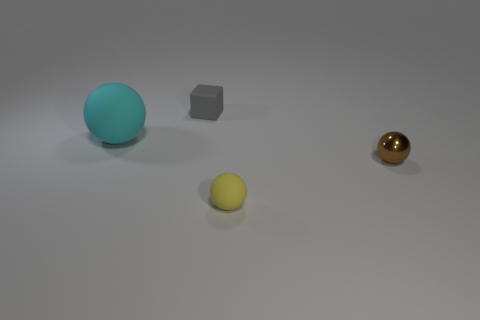Add 2 big green rubber cylinders. How many objects exist? 6 Subtract all balls. How many objects are left? 1 Add 1 tiny cyan metallic things. How many tiny cyan metallic things exist? 1 Subtract 1 yellow spheres. How many objects are left? 3 Subtract all tiny shiny things. Subtract all small brown objects. How many objects are left? 2 Add 1 brown things. How many brown things are left? 2 